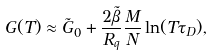Convert formula to latex. <formula><loc_0><loc_0><loc_500><loc_500>G ( T ) \approx \tilde { G } _ { 0 } + \frac { 2 \tilde { \beta } } { R _ { q } } \frac { M } { N } \ln ( T \tau _ { D } ) ,</formula> 